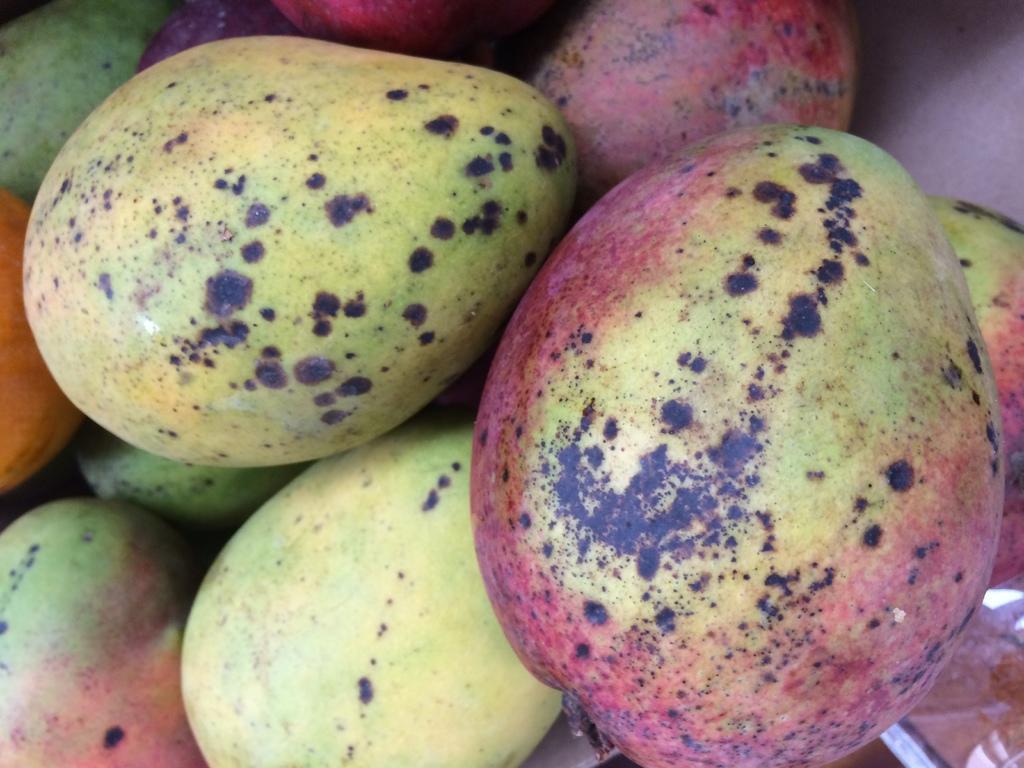How would you summarize this image in a sentence or two? In the image there are mangoes. 